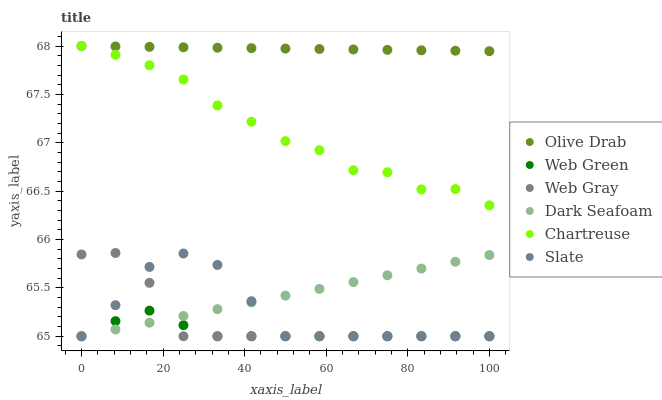Does Web Green have the minimum area under the curve?
Answer yes or no. Yes. Does Olive Drab have the maximum area under the curve?
Answer yes or no. Yes. Does Slate have the minimum area under the curve?
Answer yes or no. No. Does Slate have the maximum area under the curve?
Answer yes or no. No. Is Olive Drab the smoothest?
Answer yes or no. Yes. Is Chartreuse the roughest?
Answer yes or no. Yes. Is Slate the smoothest?
Answer yes or no. No. Is Slate the roughest?
Answer yes or no. No. Does Web Gray have the lowest value?
Answer yes or no. Yes. Does Chartreuse have the lowest value?
Answer yes or no. No. Does Olive Drab have the highest value?
Answer yes or no. Yes. Does Slate have the highest value?
Answer yes or no. No. Is Slate less than Chartreuse?
Answer yes or no. Yes. Is Chartreuse greater than Web Green?
Answer yes or no. Yes. Does Slate intersect Dark Seafoam?
Answer yes or no. Yes. Is Slate less than Dark Seafoam?
Answer yes or no. No. Is Slate greater than Dark Seafoam?
Answer yes or no. No. Does Slate intersect Chartreuse?
Answer yes or no. No. 